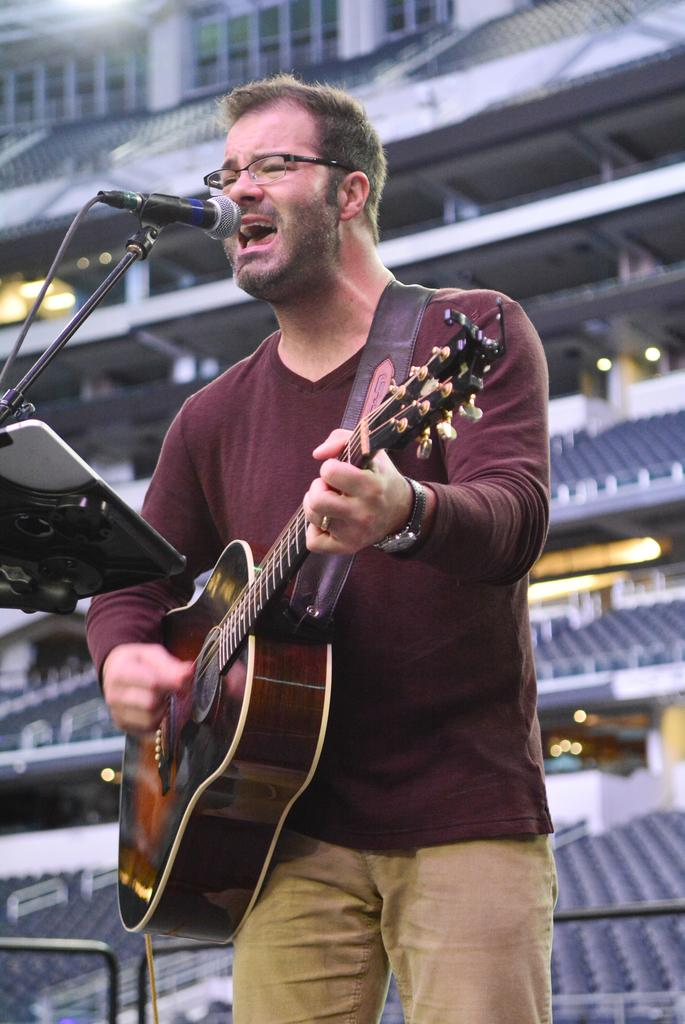What is the man in the image doing? The man is standing in the image and singing a song while playing a guitar. What is the man using to amplify his voice? There is a microphone attached to a microphone stand in the image. What can be inferred about the location of the image? The background of the image appears to be a stadium. What type of feast is being prepared in the image? There is no feast being prepared in the image; it features a man singing and playing a guitar in a stadium setting. Can you tell me how many letters are visible in the image? There is no mention of letters in the provided facts, so it is not possible to determine how many letters are visible in the image. 